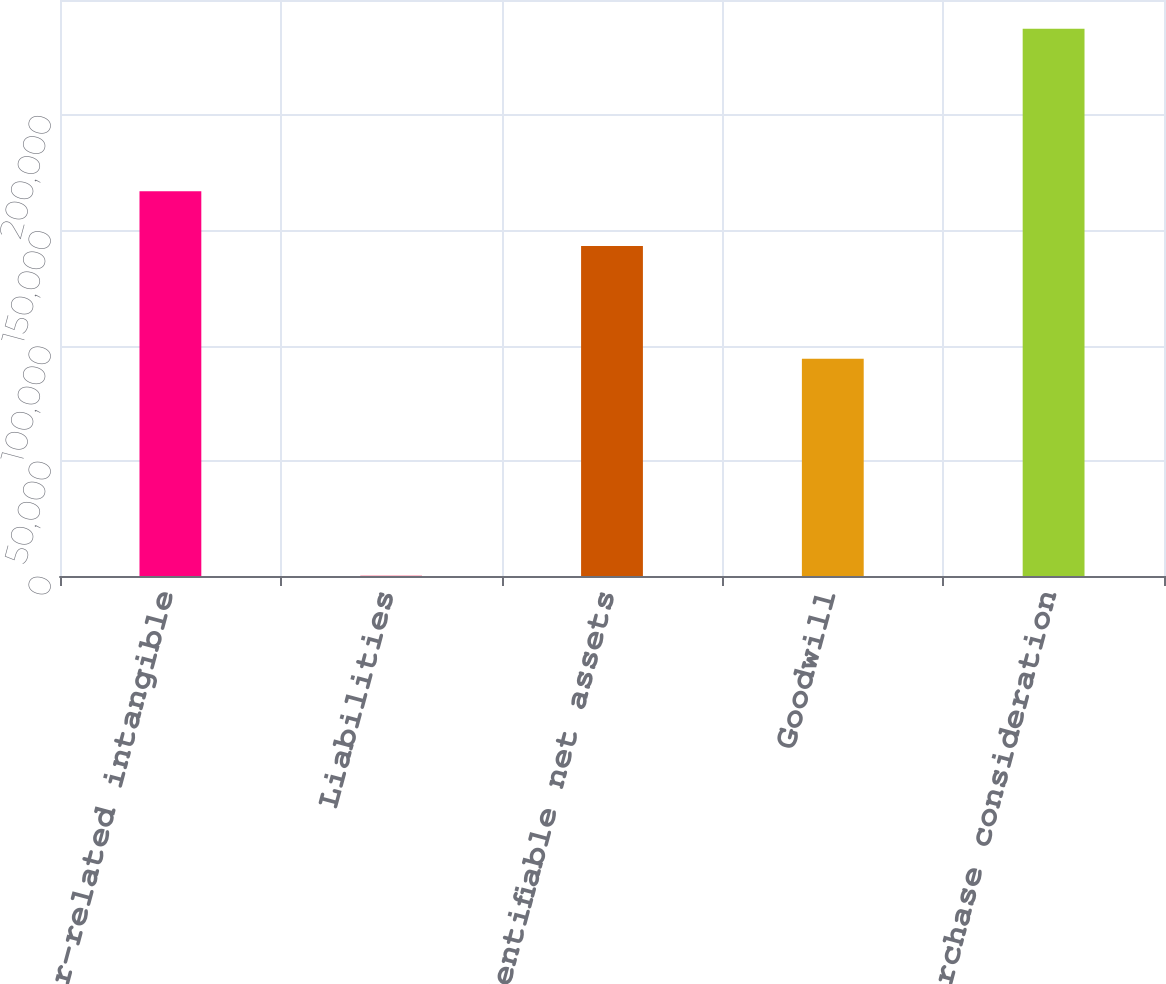<chart> <loc_0><loc_0><loc_500><loc_500><bar_chart><fcel>Customer-related intangible<fcel>Liabilities<fcel>Total identifiable net assets<fcel>Goodwill<fcel>Total purchase consideration<nl><fcel>166985<fcel>150<fcel>143250<fcel>94250<fcel>237500<nl></chart> 